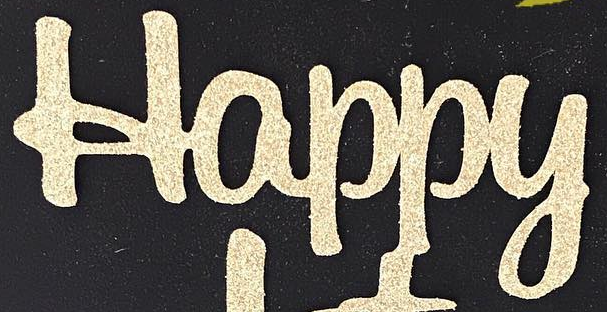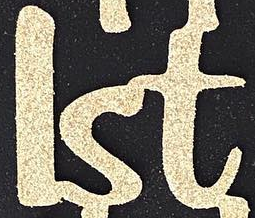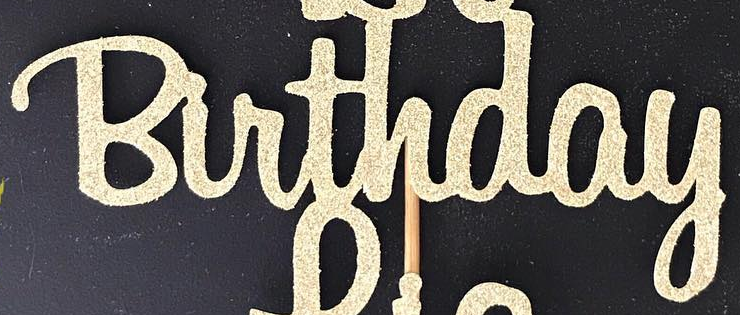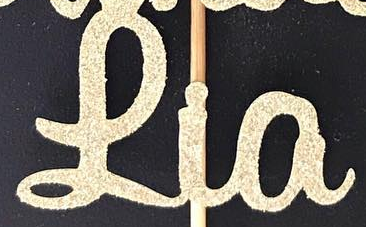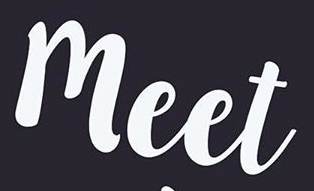Identify the words shown in these images in order, separated by a semicolon. Happy; lst; Birthday; Lia; meet 